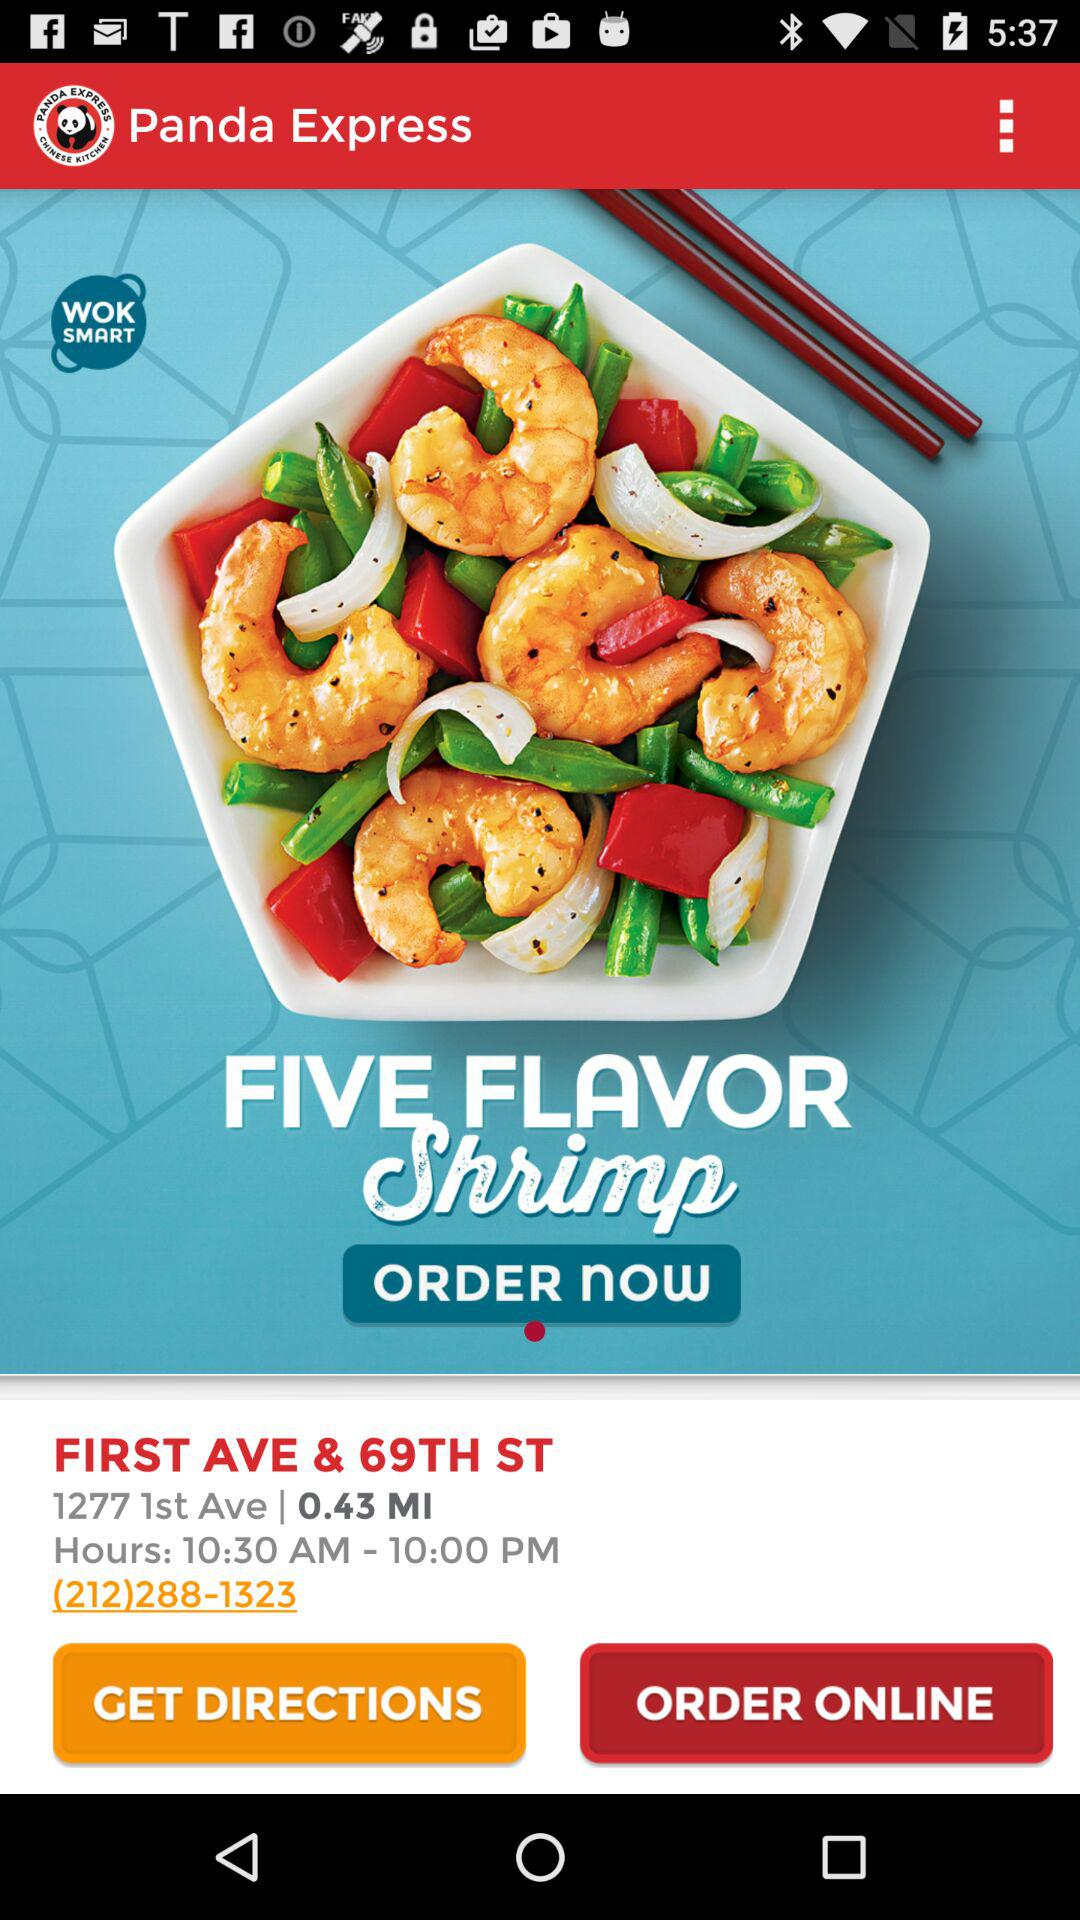What is the restaurant's name? The restaurant's name is "Panda Express". 